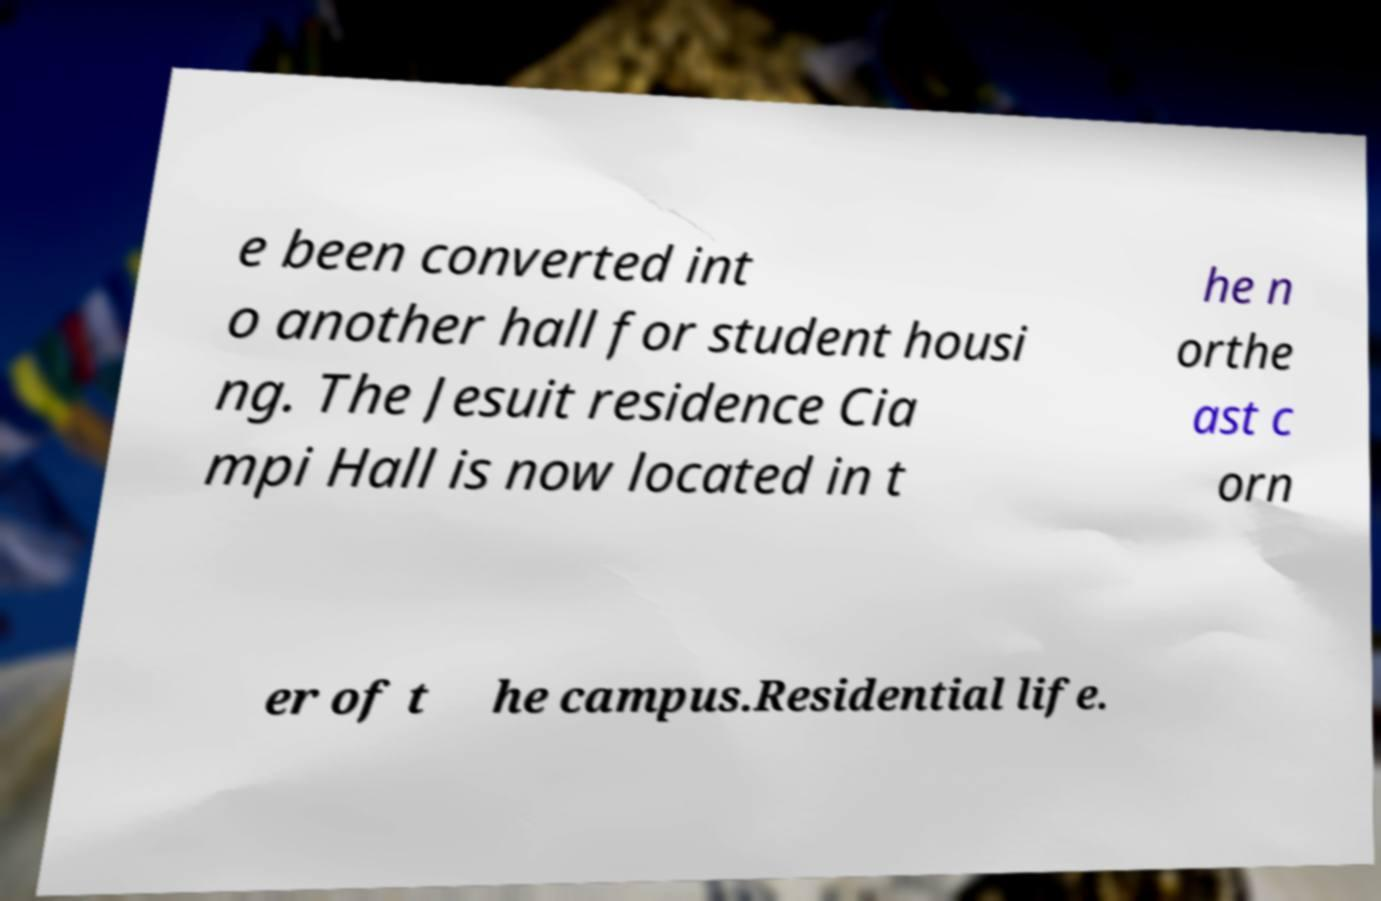Could you assist in decoding the text presented in this image and type it out clearly? e been converted int o another hall for student housi ng. The Jesuit residence Cia mpi Hall is now located in t he n orthe ast c orn er of t he campus.Residential life. 